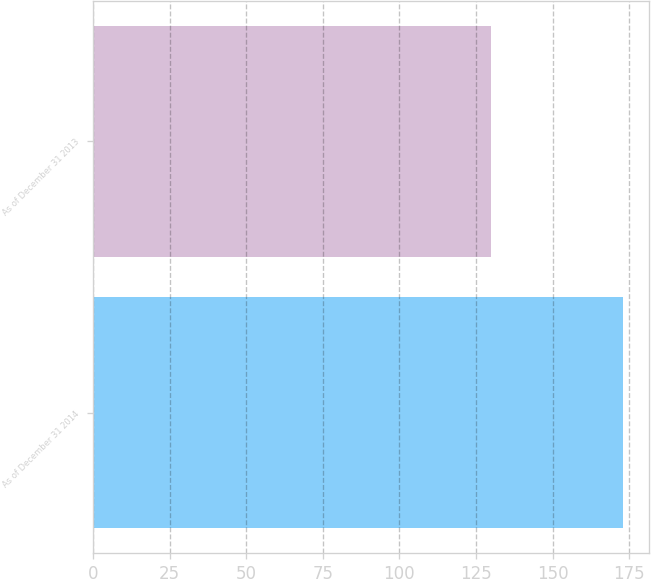Convert chart to OTSL. <chart><loc_0><loc_0><loc_500><loc_500><bar_chart><fcel>As of December 31 2014<fcel>As of December 31 2013<nl><fcel>173<fcel>130<nl></chart> 